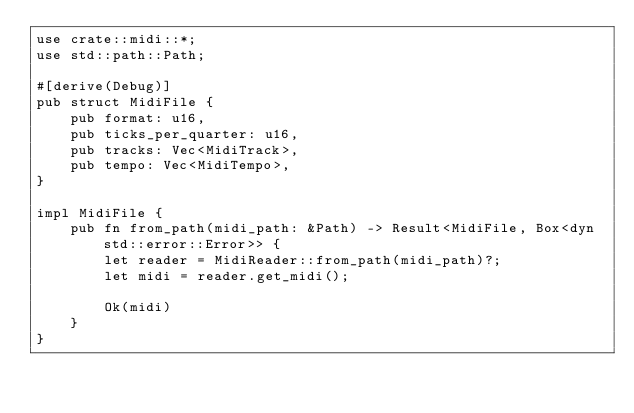<code> <loc_0><loc_0><loc_500><loc_500><_Rust_>use crate::midi::*;
use std::path::Path;

#[derive(Debug)]
pub struct MidiFile {
    pub format: u16,
    pub ticks_per_quarter: u16,
    pub tracks: Vec<MidiTrack>,
    pub tempo: Vec<MidiTempo>,
}

impl MidiFile {
    pub fn from_path(midi_path: &Path) -> Result<MidiFile, Box<dyn std::error::Error>> {
        let reader = MidiReader::from_path(midi_path)?;
        let midi = reader.get_midi();

        Ok(midi)
    }
}</code> 